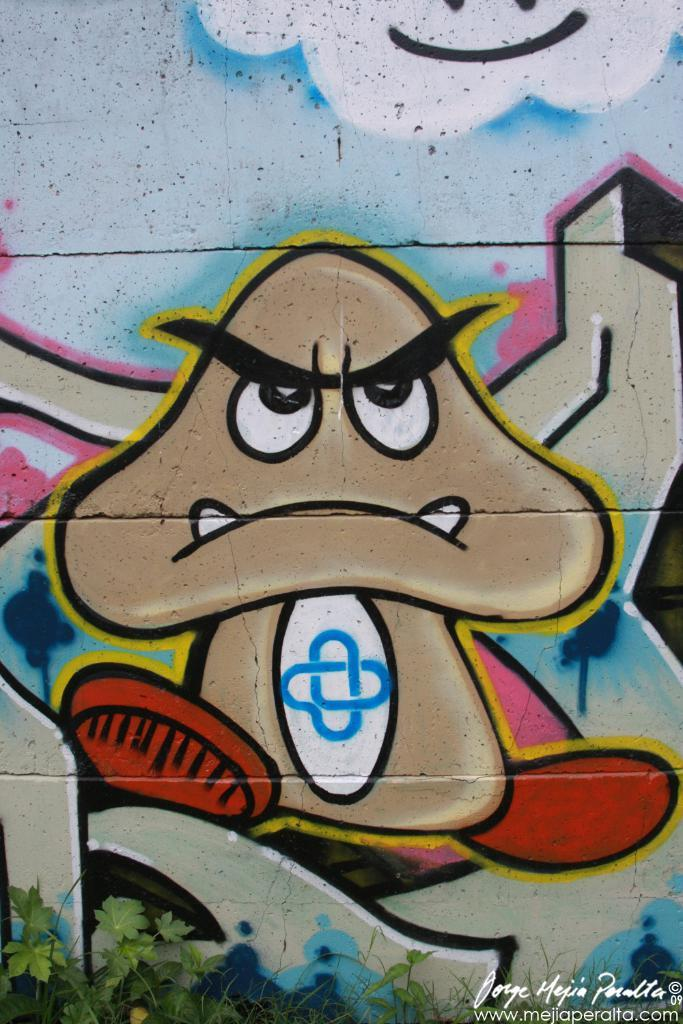What type of vegetation can be seen in the image? There are plants and grass in the image. What is the background of the image? The background of the image includes a painting on the wall. Is there any text visible in the image? Yes, there is text visible in the bottom right side of the image. What type of pear is being used to draw on the wall in the image? There is no pear present in the image, nor is there any drawing on the wall. 